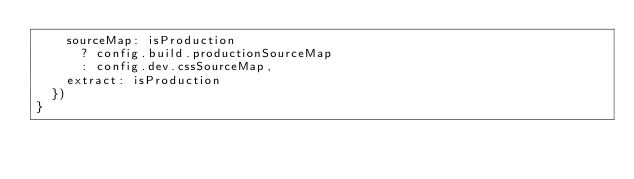<code> <loc_0><loc_0><loc_500><loc_500><_JavaScript_>    sourceMap: isProduction
      ? config.build.productionSourceMap
      : config.dev.cssSourceMap,
    extract: isProduction
  })
}
</code> 